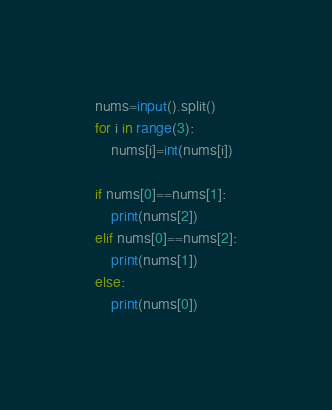<code> <loc_0><loc_0><loc_500><loc_500><_Python_>nums=input().split()
for i in range(3):
    nums[i]=int(nums[i])

if nums[0]==nums[1]:
    print(nums[2])
elif nums[0]==nums[2]:
    print(nums[1])
else:
    print(nums[0])</code> 